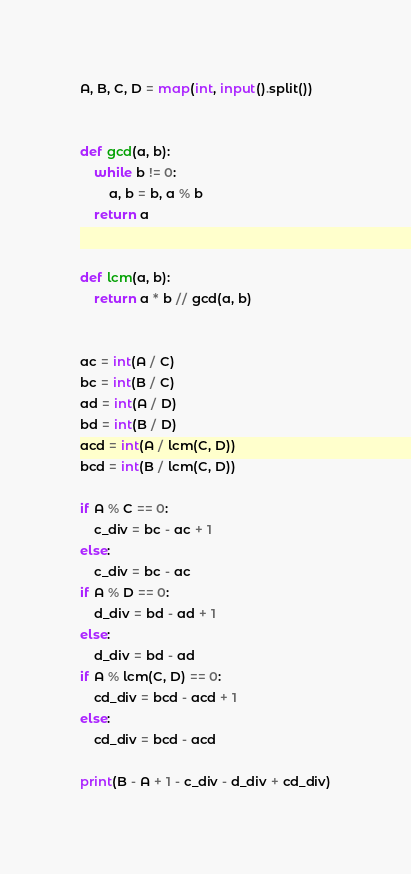<code> <loc_0><loc_0><loc_500><loc_500><_Python_>A, B, C, D = map(int, input().split())


def gcd(a, b):
    while b != 0:
        a, b = b, a % b
    return a


def lcm(a, b):
    return a * b // gcd(a, b)


ac = int(A / C)
bc = int(B / C)
ad = int(A / D)
bd = int(B / D)
acd = int(A / lcm(C, D))
bcd = int(B / lcm(C, D))

if A % C == 0:
    c_div = bc - ac + 1
else:
    c_div = bc - ac
if A % D == 0:
    d_div = bd - ad + 1
else:
    d_div = bd - ad
if A % lcm(C, D) == 0:
    cd_div = bcd - acd + 1
else:
    cd_div = bcd - acd

print(B - A + 1 - c_div - d_div + cd_div)</code> 